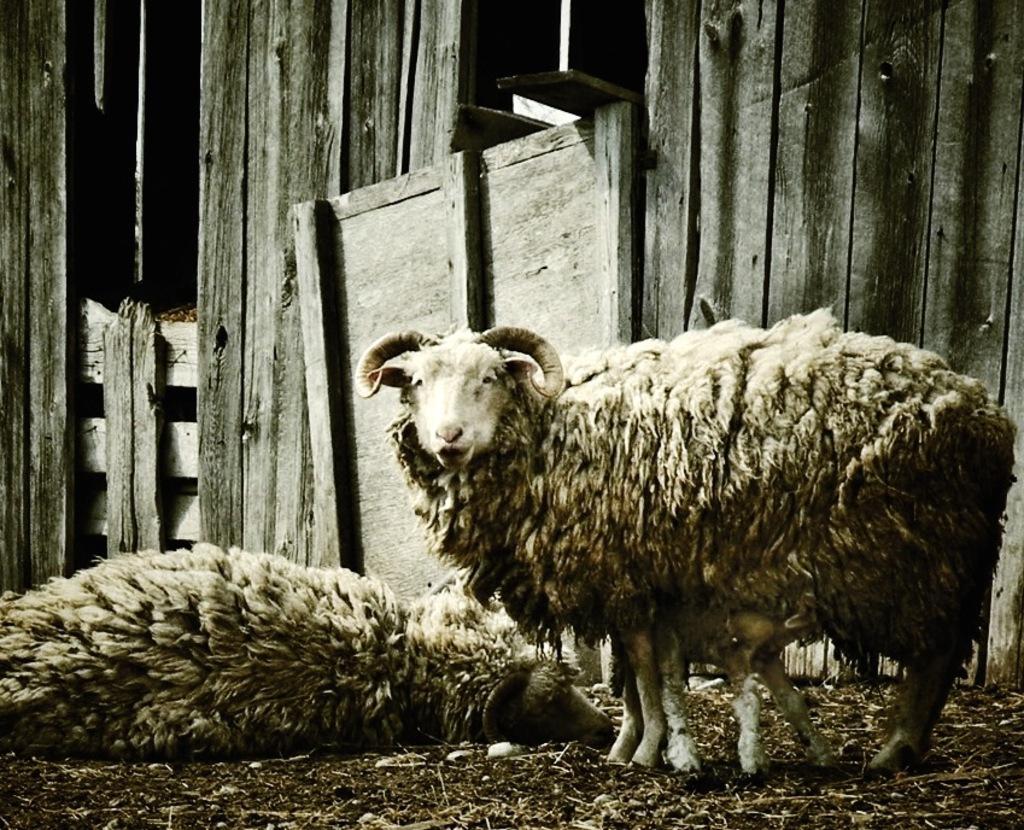Please provide a concise description of this image. This is an edited image. In this picture we can see the sheep. In the background of the image we can see the wood wall. At the bottom of the image we can see the ground. 